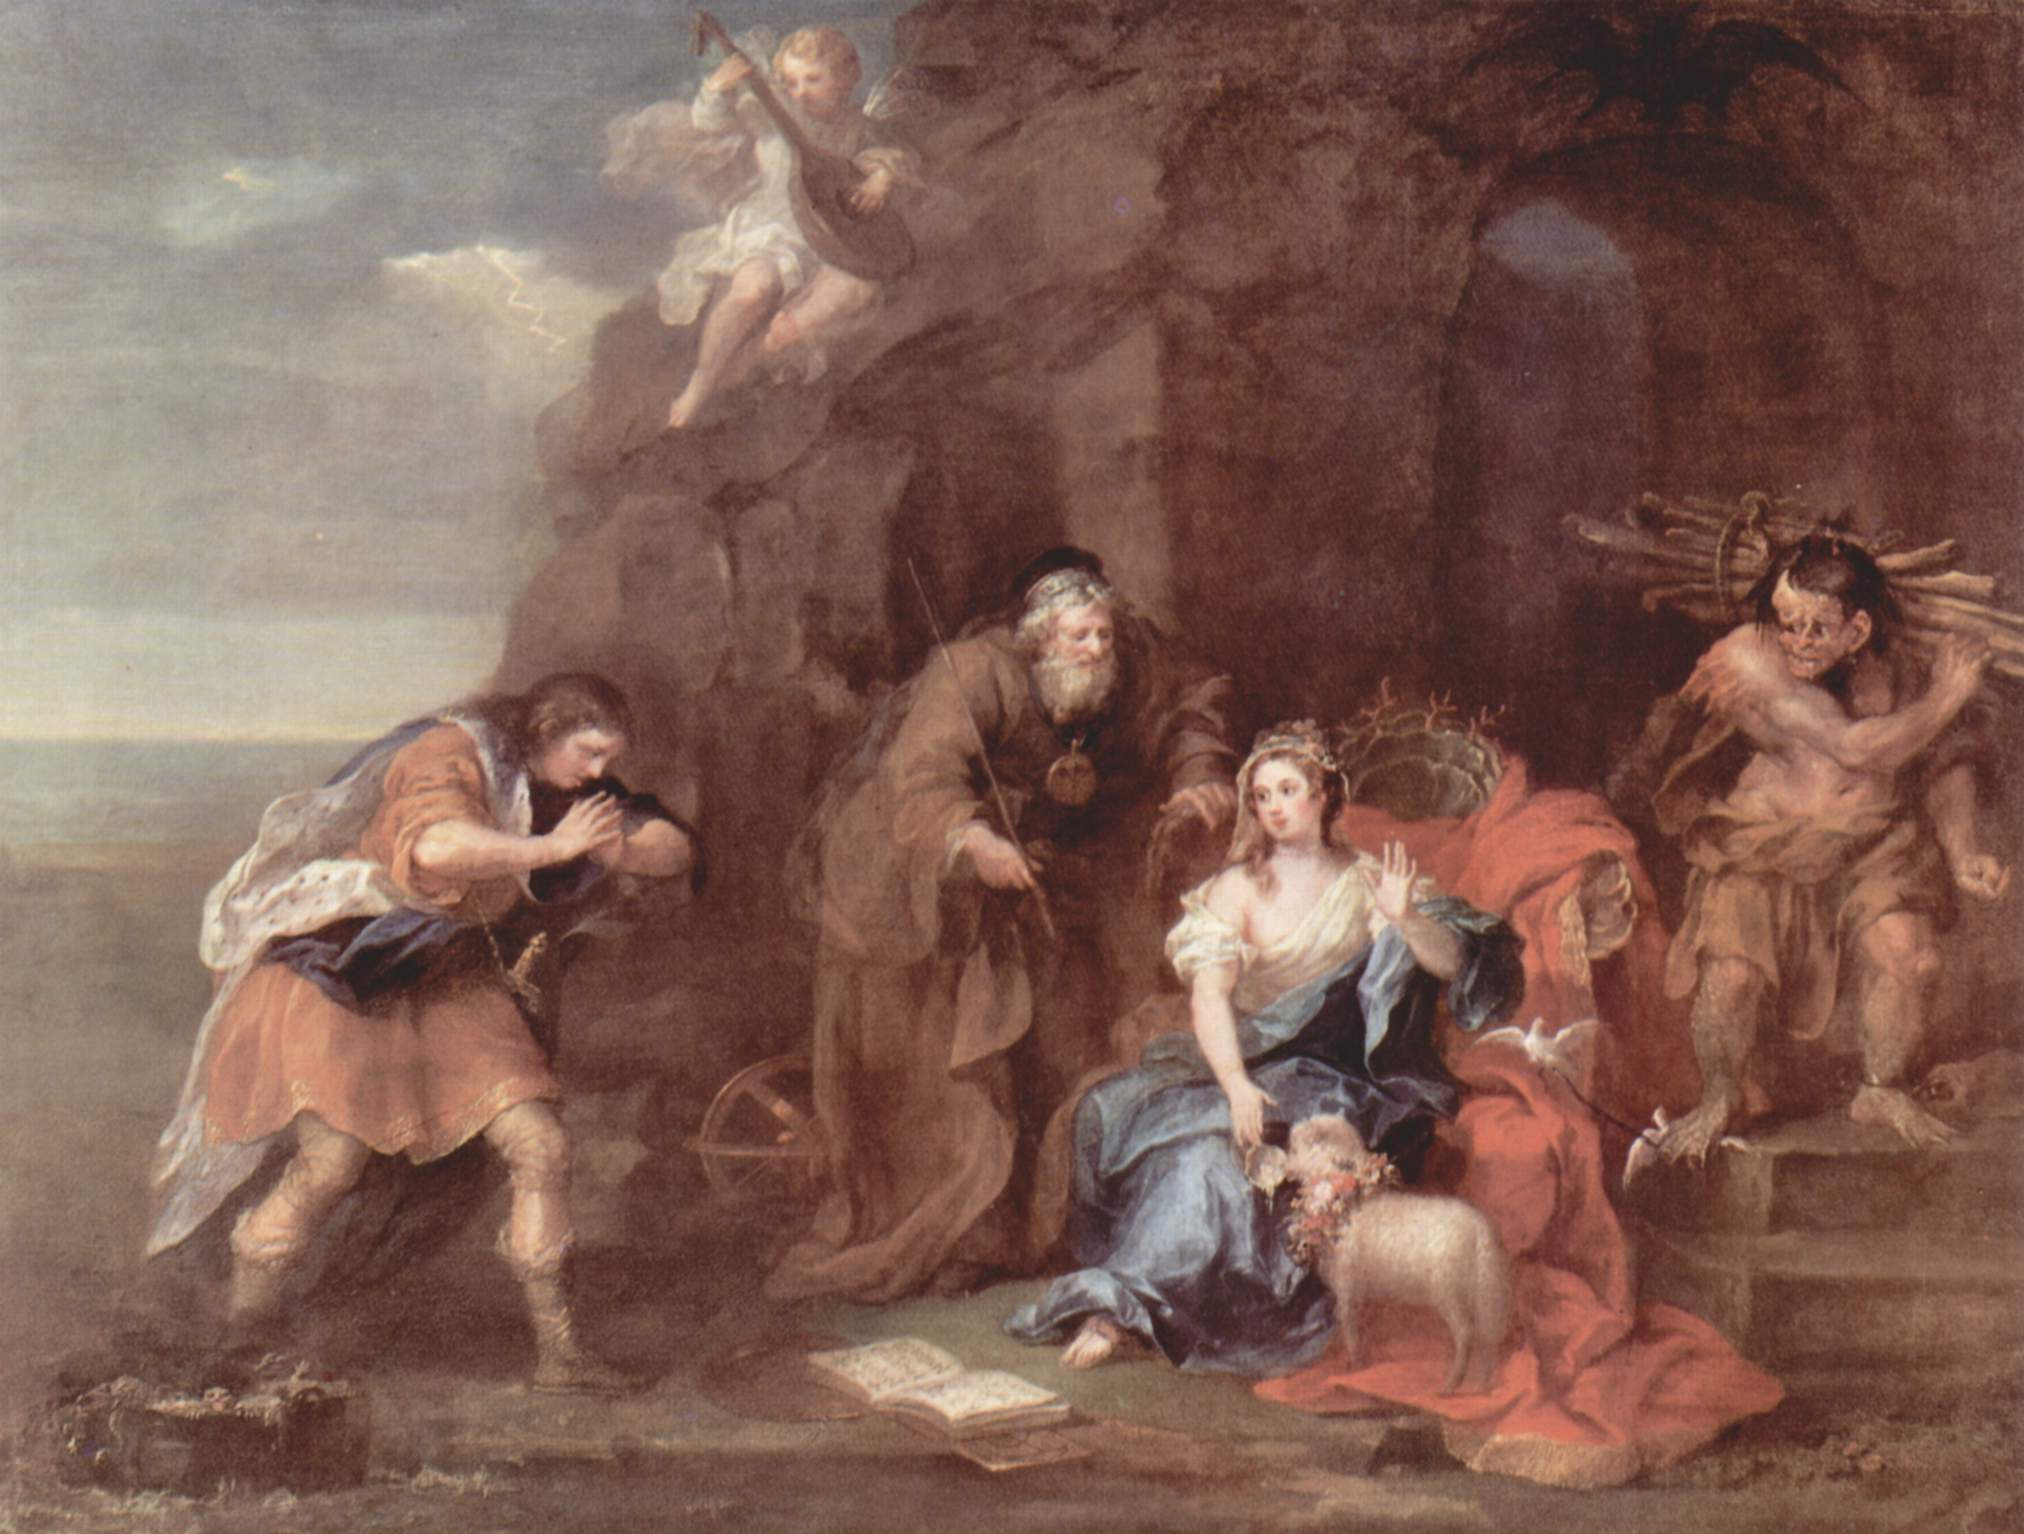What emotions do you think the artist is trying to evoke with this painting? The artist appears to evoke a range of emotions that span tranquility, introspection, and festivity. The serene expression of the reclining woman, engrossed in her book, suggests a sense of calm and intellectual engagement. The presence of the cherubs with their garland of flowers imbues the scene with a joyous, celebratory atmosphere. Meanwhile, the dynamic tension between light and shadow typical of the Baroque style adds a layer of drama and intrigue. The blend of these elements invites the viewer to reflect on the harmonized coexistence of peace, joy, and contemplation. Can you explain the significance of the musical elements in the painting? The musical elements in the painting, specifically the man playing the flute, play a crucial role in enhancing the overall ambiance and storytelling. Music, in classical art, is often associated with harmony, cultural refinement, and emotional expression. The flute player's presence suggests a narrative of entertainment or celebration, possibly alluding to the pastoral or Arcadian themes common in Baroque art. Additionally, the ethereal quality of the cherubs and their connection to music evokes a divine or heavenly context, as cherubs are often depicted as messengers of the gods or symbols of divine love and joy. The inclusion of these musical elements enriches the scene, making it multidimensional and engaging. 